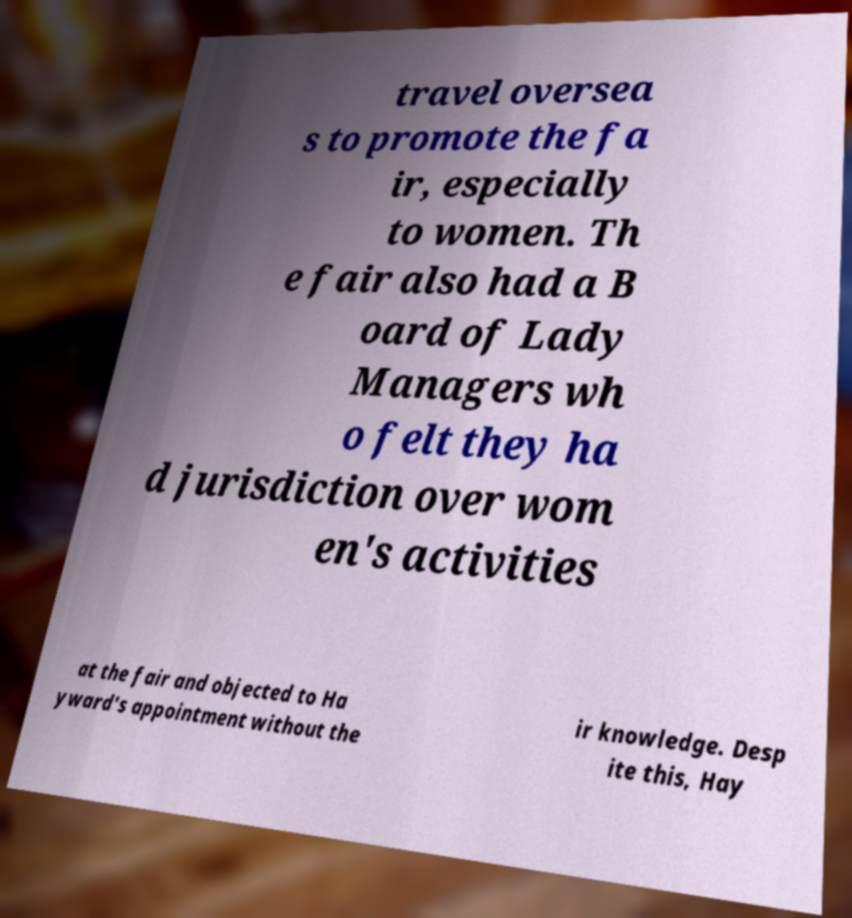Can you read and provide the text displayed in the image?This photo seems to have some interesting text. Can you extract and type it out for me? travel oversea s to promote the fa ir, especially to women. Th e fair also had a B oard of Lady Managers wh o felt they ha d jurisdiction over wom en's activities at the fair and objected to Ha yward's appointment without the ir knowledge. Desp ite this, Hay 